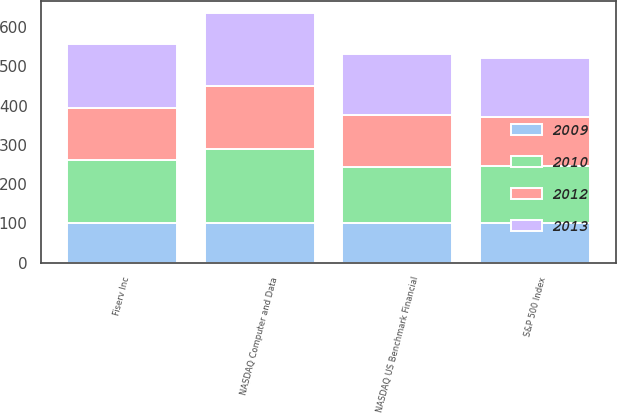Convert chart to OTSL. <chart><loc_0><loc_0><loc_500><loc_500><stacked_bar_chart><ecel><fcel>Fiserv Inc<fcel>S&P 500 Index<fcel>NASDAQ US Benchmark Financial<fcel>NASDAQ Computer and Data<nl><fcel>2009<fcel>100<fcel>100<fcel>100<fcel>100<nl><fcel>2012<fcel>133<fcel>126<fcel>132<fcel>162<nl><fcel>2010<fcel>161<fcel>146<fcel>143<fcel>189<nl><fcel>2013<fcel>162<fcel>149<fcel>156<fcel>184<nl></chart> 